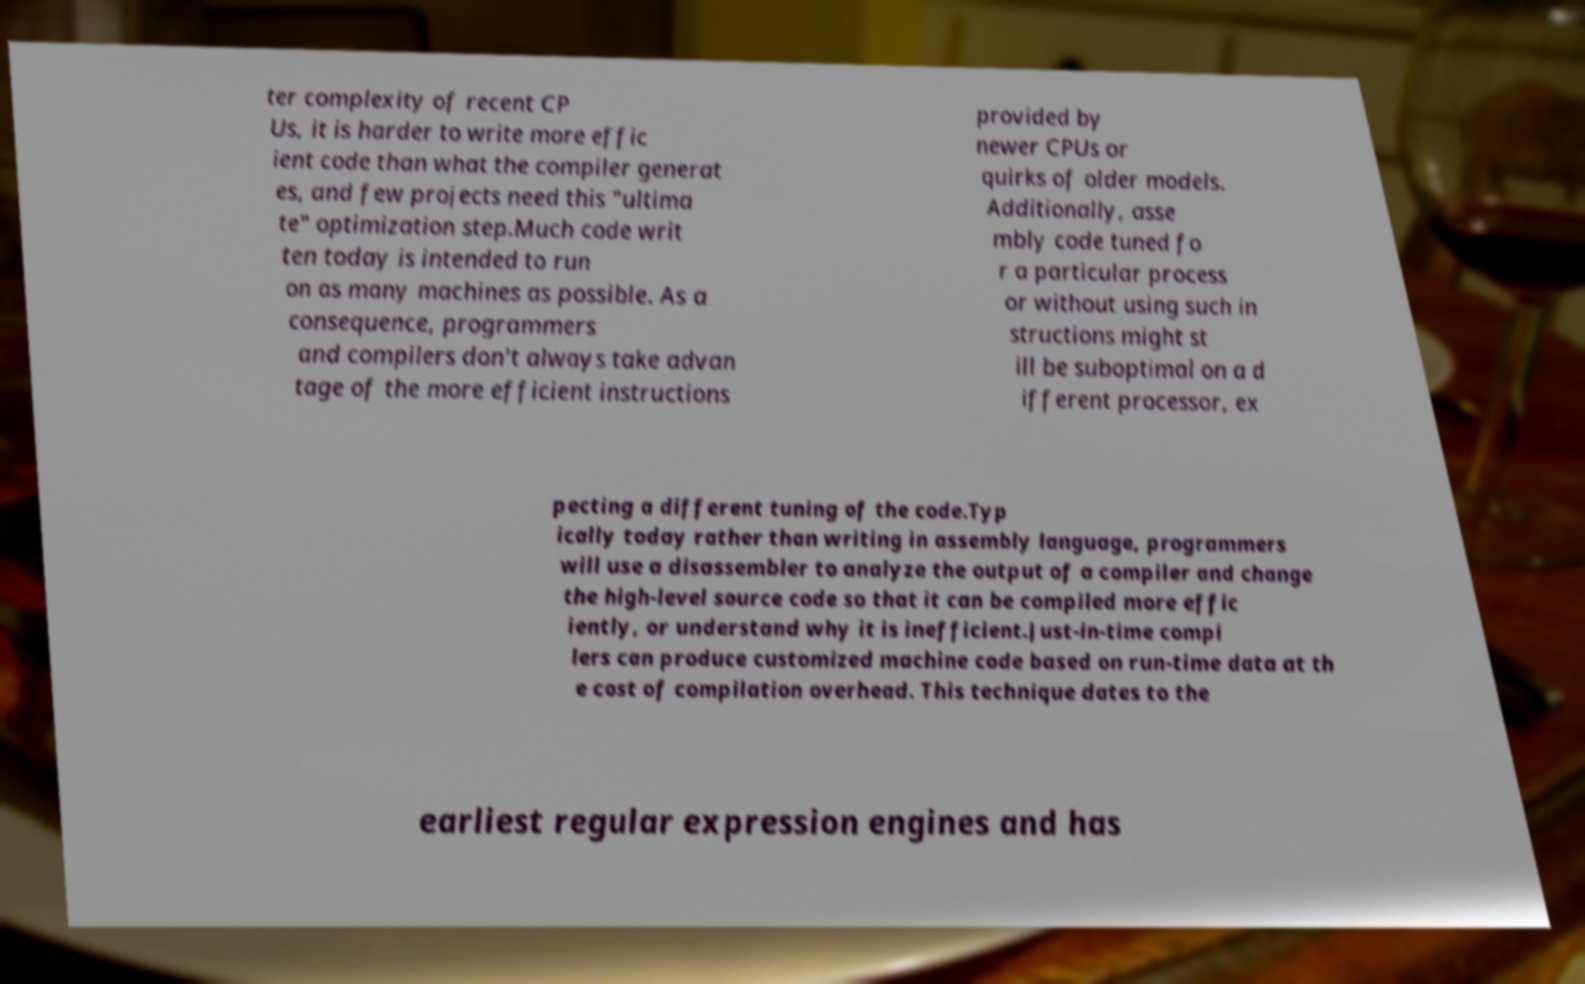Please read and relay the text visible in this image. What does it say? ter complexity of recent CP Us, it is harder to write more effic ient code than what the compiler generat es, and few projects need this "ultima te" optimization step.Much code writ ten today is intended to run on as many machines as possible. As a consequence, programmers and compilers don't always take advan tage of the more efficient instructions provided by newer CPUs or quirks of older models. Additionally, asse mbly code tuned fo r a particular process or without using such in structions might st ill be suboptimal on a d ifferent processor, ex pecting a different tuning of the code.Typ ically today rather than writing in assembly language, programmers will use a disassembler to analyze the output of a compiler and change the high-level source code so that it can be compiled more effic iently, or understand why it is inefficient.Just-in-time compi lers can produce customized machine code based on run-time data at th e cost of compilation overhead. This technique dates to the earliest regular expression engines and has 